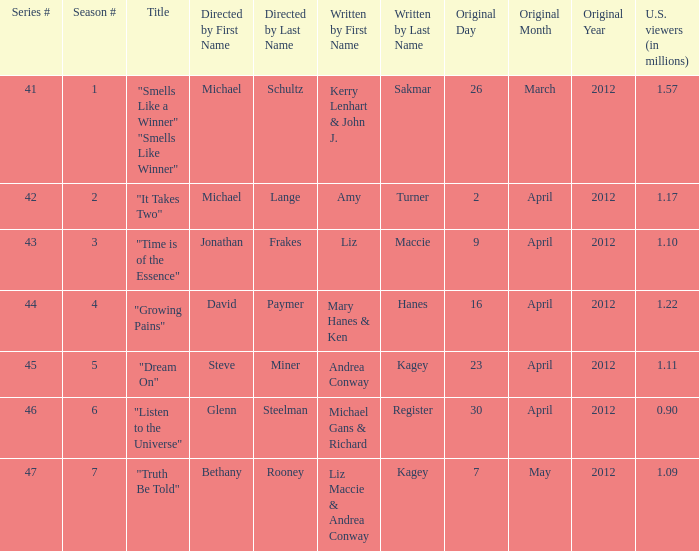What are the titles of the episodes which had 1.10 million U.S. viewers? "Time is of the Essence". 